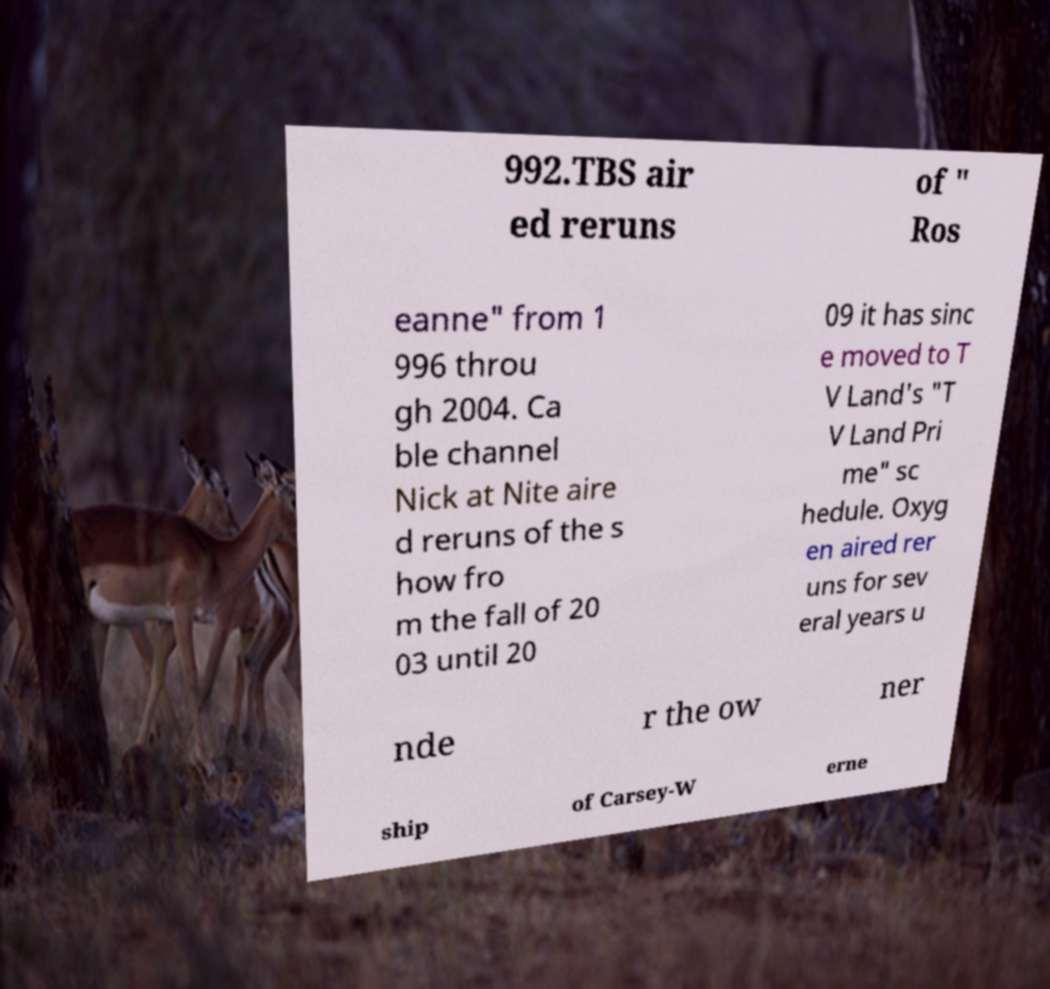Can you read and provide the text displayed in the image?This photo seems to have some interesting text. Can you extract and type it out for me? 992.TBS air ed reruns of " Ros eanne" from 1 996 throu gh 2004. Ca ble channel Nick at Nite aire d reruns of the s how fro m the fall of 20 03 until 20 09 it has sinc e moved to T V Land's "T V Land Pri me" sc hedule. Oxyg en aired rer uns for sev eral years u nde r the ow ner ship of Carsey-W erne 